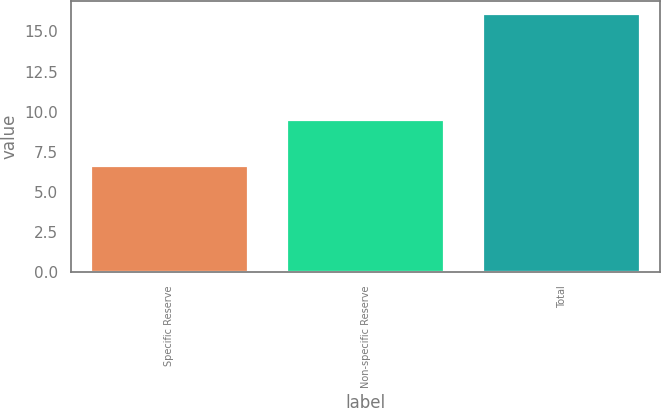Convert chart. <chart><loc_0><loc_0><loc_500><loc_500><bar_chart><fcel>Specific Reserve<fcel>Non-specific Reserve<fcel>Total<nl><fcel>6.6<fcel>9.5<fcel>16.1<nl></chart> 